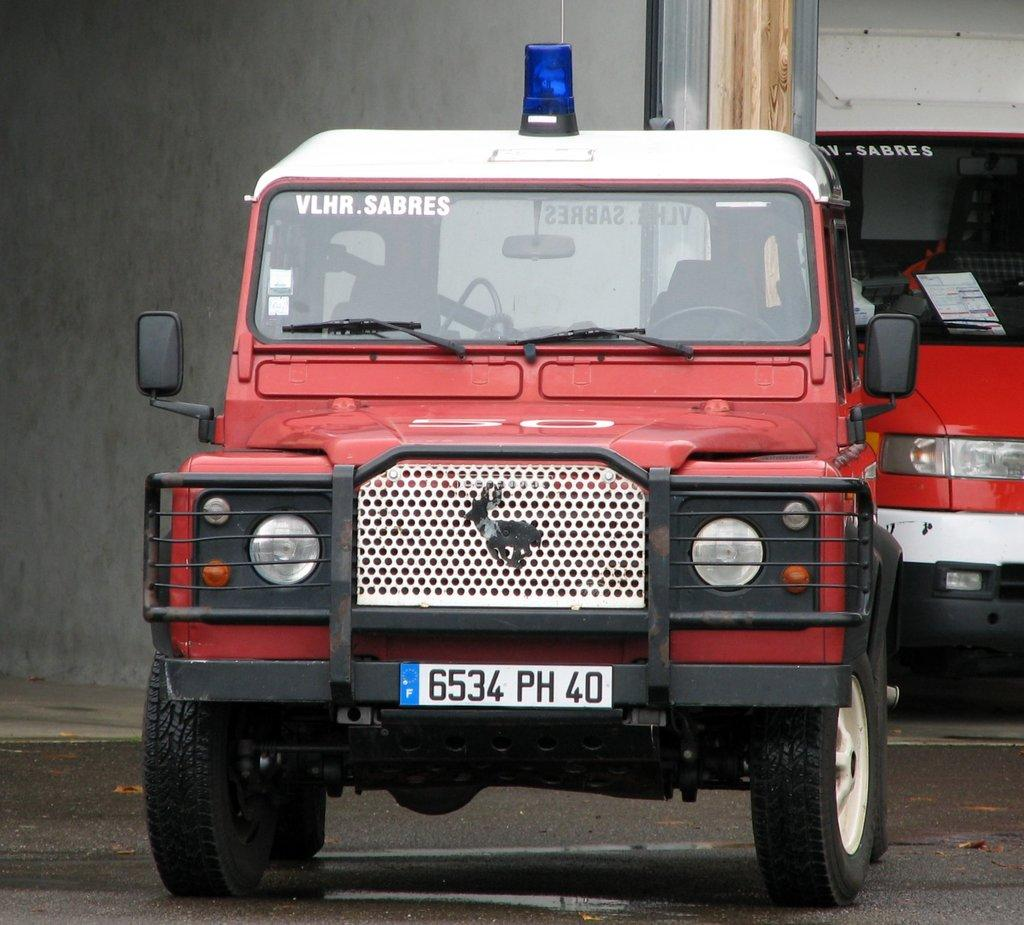What type of vehicles are present in the image? There are red color trucks in the image. What else can be seen in the image besides the trucks? There are buildings in the image. What type of glove is the laborer wearing in the image? There is no laborer or glove present in the image; it only features red color trucks and buildings. 